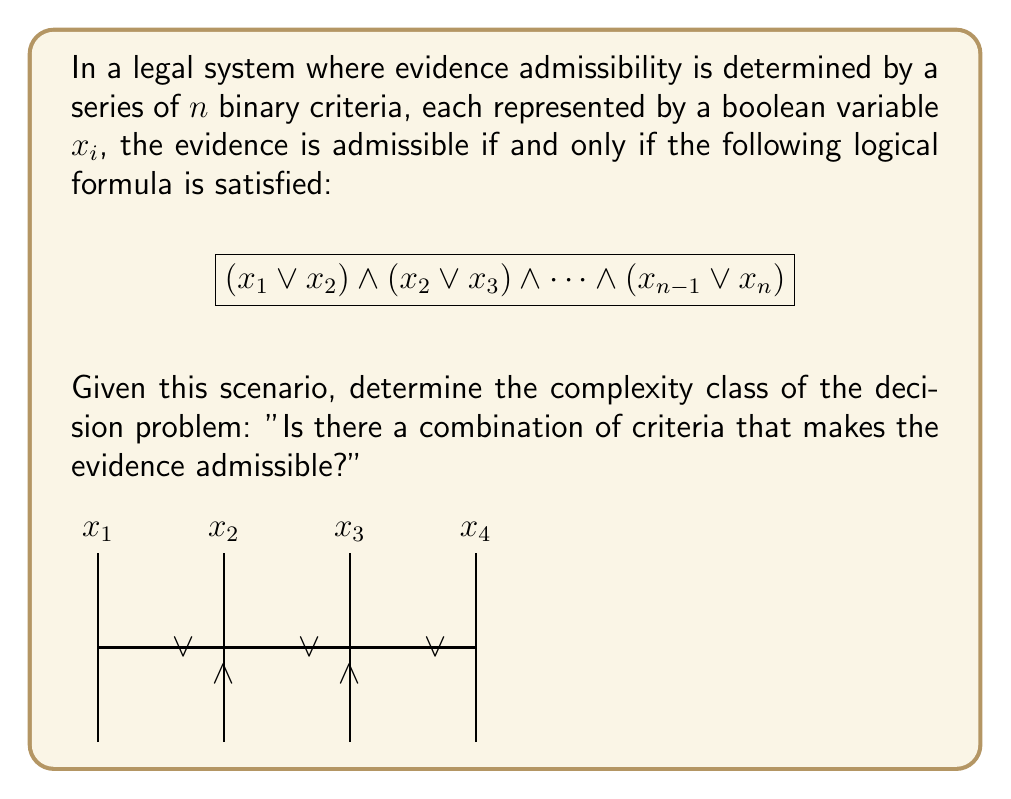Solve this math problem. Let's approach this step-by-step:

1) First, we need to recognize the structure of the given logical formula. It's a conjunction of disjunctions, where each disjunction involves two adjacent variables.

2) This structure is known as 2-SAT (2-Satisfiability), because each clause (disjunction) contains exactly two literals.

3) The decision problem asks whether there exists a satisfying assignment for this 2-SAT formula.

4) In computational complexity theory, 2-SAT is a well-known problem with a polynomial-time solution.

5) Specifically, 2-SAT belongs to the complexity class P (Polynomial time).

6) There are several algorithms that can solve 2-SAT in polynomial time. One of the most straightforward is based on the concept of strongly connected components in a graph.

7) The algorithm works by creating an implication graph from the 2-SAT formula and then finding strongly connected components. If no variable and its negation are in the same strongly connected component, the formula is satisfiable.

8) This algorithm runs in $O(n+m)$ time, where $n$ is the number of variables and $m$ is the number of clauses. In our case, both $n$ and $m$ are linear in terms of the input size.

9) Therefore, the decision problem "Is there a combination of criteria that makes the evidence admissible?" can be solved in polynomial time.

10) This places the problem squarely in the complexity class P.
Answer: P (Polynomial time) 